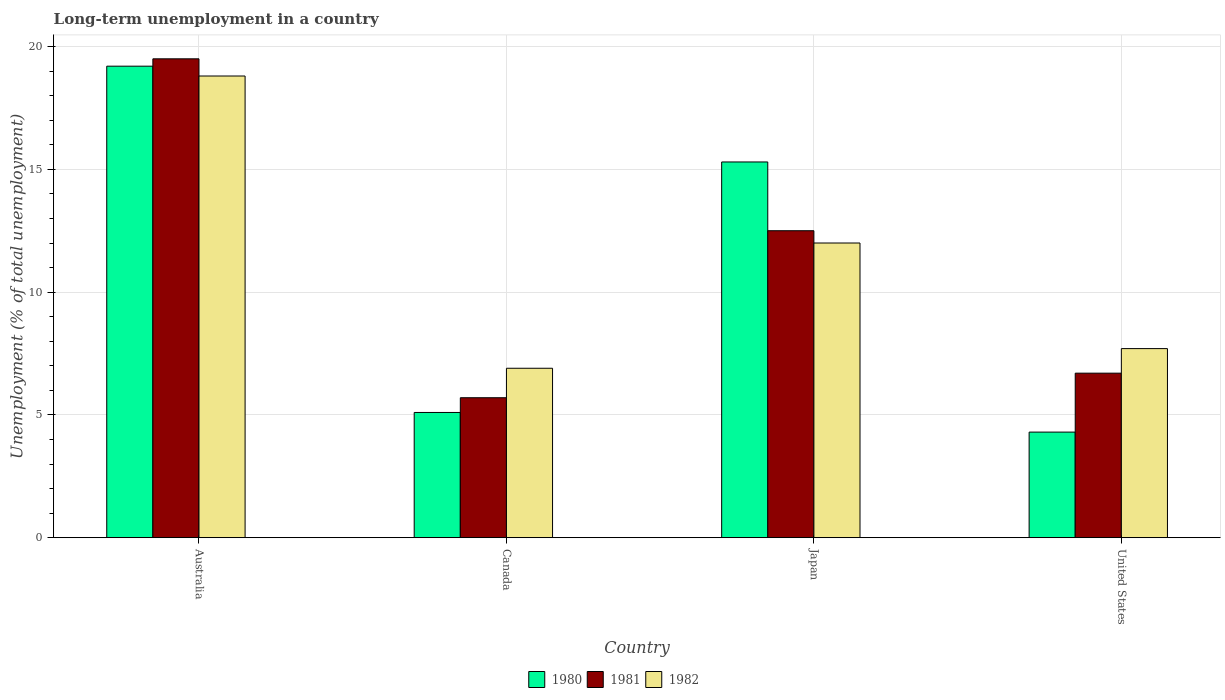How many different coloured bars are there?
Your response must be concise. 3. Are the number of bars per tick equal to the number of legend labels?
Your answer should be compact. Yes. How many bars are there on the 1st tick from the right?
Offer a very short reply. 3. What is the label of the 2nd group of bars from the left?
Make the answer very short. Canada. Across all countries, what is the maximum percentage of long-term unemployed population in 1980?
Offer a terse response. 19.2. Across all countries, what is the minimum percentage of long-term unemployed population in 1981?
Offer a very short reply. 5.7. In which country was the percentage of long-term unemployed population in 1980 minimum?
Offer a terse response. United States. What is the total percentage of long-term unemployed population in 1980 in the graph?
Your answer should be very brief. 43.9. What is the difference between the percentage of long-term unemployed population in 1980 in Canada and that in United States?
Your response must be concise. 0.8. What is the difference between the percentage of long-term unemployed population in 1980 in Australia and the percentage of long-term unemployed population in 1981 in United States?
Your answer should be compact. 12.5. What is the average percentage of long-term unemployed population in 1982 per country?
Offer a very short reply. 11.35. What is the difference between the percentage of long-term unemployed population of/in 1981 and percentage of long-term unemployed population of/in 1982 in Canada?
Make the answer very short. -1.2. In how many countries, is the percentage of long-term unemployed population in 1982 greater than 11 %?
Ensure brevity in your answer.  2. What is the ratio of the percentage of long-term unemployed population in 1981 in Japan to that in United States?
Your answer should be very brief. 1.87. Is the difference between the percentage of long-term unemployed population in 1981 in Japan and United States greater than the difference between the percentage of long-term unemployed population in 1982 in Japan and United States?
Ensure brevity in your answer.  Yes. What is the difference between the highest and the lowest percentage of long-term unemployed population in 1982?
Make the answer very short. 11.9. In how many countries, is the percentage of long-term unemployed population in 1981 greater than the average percentage of long-term unemployed population in 1981 taken over all countries?
Your response must be concise. 2. Is the sum of the percentage of long-term unemployed population in 1980 in Australia and Canada greater than the maximum percentage of long-term unemployed population in 1981 across all countries?
Your answer should be compact. Yes. What does the 2nd bar from the right in United States represents?
Provide a succinct answer. 1981. How many bars are there?
Offer a very short reply. 12. Are all the bars in the graph horizontal?
Make the answer very short. No. What is the difference between two consecutive major ticks on the Y-axis?
Provide a short and direct response. 5. Are the values on the major ticks of Y-axis written in scientific E-notation?
Your response must be concise. No. Does the graph contain grids?
Your answer should be compact. Yes. Where does the legend appear in the graph?
Your answer should be compact. Bottom center. How are the legend labels stacked?
Your response must be concise. Horizontal. What is the title of the graph?
Keep it short and to the point. Long-term unemployment in a country. What is the label or title of the X-axis?
Your response must be concise. Country. What is the label or title of the Y-axis?
Your response must be concise. Unemployment (% of total unemployment). What is the Unemployment (% of total unemployment) of 1980 in Australia?
Your answer should be compact. 19.2. What is the Unemployment (% of total unemployment) in 1981 in Australia?
Provide a short and direct response. 19.5. What is the Unemployment (% of total unemployment) of 1982 in Australia?
Your response must be concise. 18.8. What is the Unemployment (% of total unemployment) of 1980 in Canada?
Your answer should be compact. 5.1. What is the Unemployment (% of total unemployment) in 1981 in Canada?
Ensure brevity in your answer.  5.7. What is the Unemployment (% of total unemployment) of 1982 in Canada?
Provide a succinct answer. 6.9. What is the Unemployment (% of total unemployment) of 1980 in Japan?
Give a very brief answer. 15.3. What is the Unemployment (% of total unemployment) in 1981 in Japan?
Your response must be concise. 12.5. What is the Unemployment (% of total unemployment) in 1982 in Japan?
Ensure brevity in your answer.  12. What is the Unemployment (% of total unemployment) of 1980 in United States?
Your answer should be compact. 4.3. What is the Unemployment (% of total unemployment) of 1981 in United States?
Provide a succinct answer. 6.7. What is the Unemployment (% of total unemployment) in 1982 in United States?
Make the answer very short. 7.7. Across all countries, what is the maximum Unemployment (% of total unemployment) in 1980?
Provide a succinct answer. 19.2. Across all countries, what is the maximum Unemployment (% of total unemployment) in 1981?
Ensure brevity in your answer.  19.5. Across all countries, what is the maximum Unemployment (% of total unemployment) in 1982?
Your response must be concise. 18.8. Across all countries, what is the minimum Unemployment (% of total unemployment) of 1980?
Your answer should be very brief. 4.3. Across all countries, what is the minimum Unemployment (% of total unemployment) in 1981?
Offer a terse response. 5.7. Across all countries, what is the minimum Unemployment (% of total unemployment) of 1982?
Your response must be concise. 6.9. What is the total Unemployment (% of total unemployment) of 1980 in the graph?
Provide a short and direct response. 43.9. What is the total Unemployment (% of total unemployment) in 1981 in the graph?
Ensure brevity in your answer.  44.4. What is the total Unemployment (% of total unemployment) in 1982 in the graph?
Your response must be concise. 45.4. What is the difference between the Unemployment (% of total unemployment) in 1981 in Australia and that in Canada?
Ensure brevity in your answer.  13.8. What is the difference between the Unemployment (% of total unemployment) of 1980 in Australia and that in Japan?
Keep it short and to the point. 3.9. What is the difference between the Unemployment (% of total unemployment) in 1982 in Australia and that in Japan?
Provide a succinct answer. 6.8. What is the difference between the Unemployment (% of total unemployment) of 1980 in Australia and that in United States?
Give a very brief answer. 14.9. What is the difference between the Unemployment (% of total unemployment) in 1981 in Australia and that in United States?
Your answer should be very brief. 12.8. What is the difference between the Unemployment (% of total unemployment) of 1982 in Australia and that in United States?
Provide a succinct answer. 11.1. What is the difference between the Unemployment (% of total unemployment) in 1981 in Canada and that in Japan?
Your answer should be compact. -6.8. What is the difference between the Unemployment (% of total unemployment) in 1982 in Canada and that in Japan?
Ensure brevity in your answer.  -5.1. What is the difference between the Unemployment (% of total unemployment) in 1981 in Japan and that in United States?
Ensure brevity in your answer.  5.8. What is the difference between the Unemployment (% of total unemployment) of 1982 in Japan and that in United States?
Provide a short and direct response. 4.3. What is the difference between the Unemployment (% of total unemployment) of 1980 in Australia and the Unemployment (% of total unemployment) of 1982 in Canada?
Keep it short and to the point. 12.3. What is the difference between the Unemployment (% of total unemployment) of 1981 in Australia and the Unemployment (% of total unemployment) of 1982 in Canada?
Offer a very short reply. 12.6. What is the difference between the Unemployment (% of total unemployment) of 1980 in Australia and the Unemployment (% of total unemployment) of 1981 in Japan?
Provide a short and direct response. 6.7. What is the difference between the Unemployment (% of total unemployment) in 1980 in Australia and the Unemployment (% of total unemployment) in 1982 in Japan?
Keep it short and to the point. 7.2. What is the difference between the Unemployment (% of total unemployment) in 1980 in Australia and the Unemployment (% of total unemployment) in 1982 in United States?
Give a very brief answer. 11.5. What is the difference between the Unemployment (% of total unemployment) of 1981 in Australia and the Unemployment (% of total unemployment) of 1982 in United States?
Your response must be concise. 11.8. What is the difference between the Unemployment (% of total unemployment) of 1980 in Canada and the Unemployment (% of total unemployment) of 1981 in Japan?
Give a very brief answer. -7.4. What is the difference between the Unemployment (% of total unemployment) of 1980 in Canada and the Unemployment (% of total unemployment) of 1982 in Japan?
Keep it short and to the point. -6.9. What is the difference between the Unemployment (% of total unemployment) in 1981 in Canada and the Unemployment (% of total unemployment) in 1982 in Japan?
Keep it short and to the point. -6.3. What is the difference between the Unemployment (% of total unemployment) of 1980 in Canada and the Unemployment (% of total unemployment) of 1982 in United States?
Provide a succinct answer. -2.6. What is the difference between the Unemployment (% of total unemployment) of 1981 in Canada and the Unemployment (% of total unemployment) of 1982 in United States?
Give a very brief answer. -2. What is the difference between the Unemployment (% of total unemployment) in 1980 in Japan and the Unemployment (% of total unemployment) in 1981 in United States?
Your answer should be compact. 8.6. What is the average Unemployment (% of total unemployment) of 1980 per country?
Give a very brief answer. 10.97. What is the average Unemployment (% of total unemployment) in 1981 per country?
Your answer should be very brief. 11.1. What is the average Unemployment (% of total unemployment) of 1982 per country?
Your answer should be compact. 11.35. What is the difference between the Unemployment (% of total unemployment) in 1980 and Unemployment (% of total unemployment) in 1981 in Australia?
Your answer should be compact. -0.3. What is the difference between the Unemployment (% of total unemployment) in 1981 and Unemployment (% of total unemployment) in 1982 in Australia?
Offer a very short reply. 0.7. What is the difference between the Unemployment (% of total unemployment) of 1980 and Unemployment (% of total unemployment) of 1982 in Canada?
Your response must be concise. -1.8. What is the difference between the Unemployment (% of total unemployment) in 1980 and Unemployment (% of total unemployment) in 1981 in Japan?
Keep it short and to the point. 2.8. What is the difference between the Unemployment (% of total unemployment) in 1981 and Unemployment (% of total unemployment) in 1982 in Japan?
Make the answer very short. 0.5. What is the difference between the Unemployment (% of total unemployment) of 1981 and Unemployment (% of total unemployment) of 1982 in United States?
Offer a terse response. -1. What is the ratio of the Unemployment (% of total unemployment) of 1980 in Australia to that in Canada?
Provide a succinct answer. 3.76. What is the ratio of the Unemployment (% of total unemployment) in 1981 in Australia to that in Canada?
Provide a succinct answer. 3.42. What is the ratio of the Unemployment (% of total unemployment) in 1982 in Australia to that in Canada?
Provide a short and direct response. 2.72. What is the ratio of the Unemployment (% of total unemployment) in 1980 in Australia to that in Japan?
Provide a short and direct response. 1.25. What is the ratio of the Unemployment (% of total unemployment) of 1981 in Australia to that in Japan?
Your response must be concise. 1.56. What is the ratio of the Unemployment (% of total unemployment) of 1982 in Australia to that in Japan?
Provide a succinct answer. 1.57. What is the ratio of the Unemployment (% of total unemployment) of 1980 in Australia to that in United States?
Keep it short and to the point. 4.47. What is the ratio of the Unemployment (% of total unemployment) of 1981 in Australia to that in United States?
Provide a short and direct response. 2.91. What is the ratio of the Unemployment (% of total unemployment) of 1982 in Australia to that in United States?
Give a very brief answer. 2.44. What is the ratio of the Unemployment (% of total unemployment) of 1981 in Canada to that in Japan?
Provide a succinct answer. 0.46. What is the ratio of the Unemployment (% of total unemployment) of 1982 in Canada to that in Japan?
Provide a short and direct response. 0.57. What is the ratio of the Unemployment (% of total unemployment) of 1980 in Canada to that in United States?
Your answer should be compact. 1.19. What is the ratio of the Unemployment (% of total unemployment) of 1981 in Canada to that in United States?
Offer a very short reply. 0.85. What is the ratio of the Unemployment (% of total unemployment) in 1982 in Canada to that in United States?
Your response must be concise. 0.9. What is the ratio of the Unemployment (% of total unemployment) in 1980 in Japan to that in United States?
Provide a short and direct response. 3.56. What is the ratio of the Unemployment (% of total unemployment) in 1981 in Japan to that in United States?
Offer a terse response. 1.87. What is the ratio of the Unemployment (% of total unemployment) in 1982 in Japan to that in United States?
Offer a very short reply. 1.56. What is the difference between the highest and the second highest Unemployment (% of total unemployment) in 1980?
Offer a very short reply. 3.9. What is the difference between the highest and the lowest Unemployment (% of total unemployment) in 1980?
Make the answer very short. 14.9. What is the difference between the highest and the lowest Unemployment (% of total unemployment) of 1981?
Keep it short and to the point. 13.8. What is the difference between the highest and the lowest Unemployment (% of total unemployment) of 1982?
Provide a succinct answer. 11.9. 